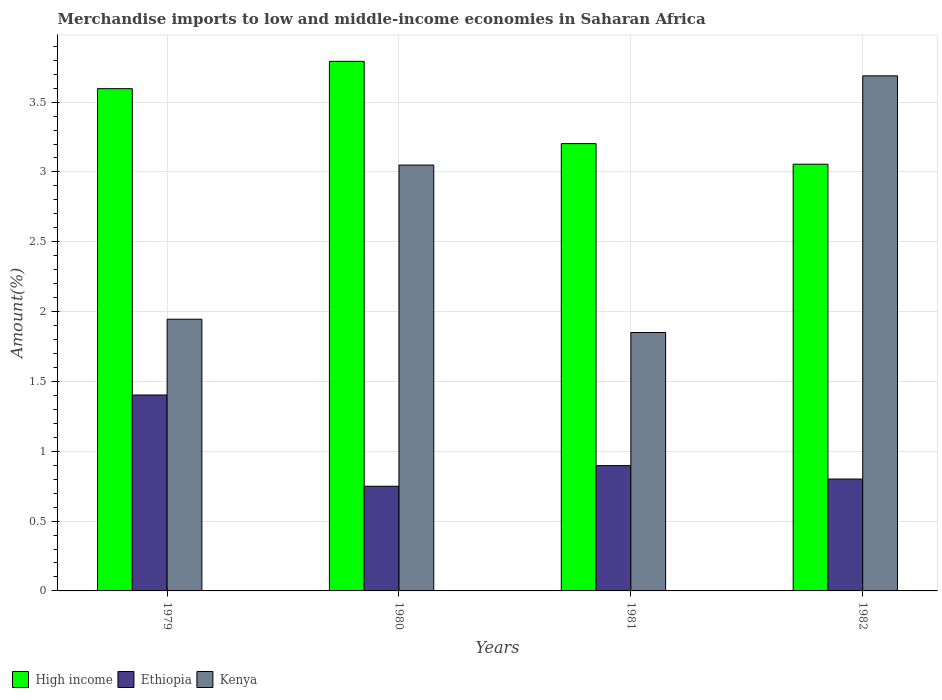How many different coloured bars are there?
Offer a very short reply. 3. How many groups of bars are there?
Ensure brevity in your answer.  4. How many bars are there on the 4th tick from the right?
Your answer should be compact. 3. What is the label of the 2nd group of bars from the left?
Make the answer very short. 1980. What is the percentage of amount earned from merchandise imports in Ethiopia in 1980?
Offer a terse response. 0.75. Across all years, what is the maximum percentage of amount earned from merchandise imports in Ethiopia?
Keep it short and to the point. 1.4. Across all years, what is the minimum percentage of amount earned from merchandise imports in Ethiopia?
Your answer should be very brief. 0.75. In which year was the percentage of amount earned from merchandise imports in Ethiopia maximum?
Provide a succinct answer. 1979. What is the total percentage of amount earned from merchandise imports in Kenya in the graph?
Your answer should be very brief. 10.53. What is the difference between the percentage of amount earned from merchandise imports in Kenya in 1979 and that in 1982?
Make the answer very short. -1.74. What is the difference between the percentage of amount earned from merchandise imports in Ethiopia in 1981 and the percentage of amount earned from merchandise imports in Kenya in 1979?
Your answer should be compact. -1.05. What is the average percentage of amount earned from merchandise imports in High income per year?
Make the answer very short. 3.41. In the year 1982, what is the difference between the percentage of amount earned from merchandise imports in Ethiopia and percentage of amount earned from merchandise imports in High income?
Make the answer very short. -2.25. In how many years, is the percentage of amount earned from merchandise imports in Kenya greater than 0.1 %?
Offer a terse response. 4. What is the ratio of the percentage of amount earned from merchandise imports in Ethiopia in 1980 to that in 1981?
Give a very brief answer. 0.84. What is the difference between the highest and the second highest percentage of amount earned from merchandise imports in High income?
Offer a very short reply. 0.2. What is the difference between the highest and the lowest percentage of amount earned from merchandise imports in Ethiopia?
Provide a succinct answer. 0.65. In how many years, is the percentage of amount earned from merchandise imports in Kenya greater than the average percentage of amount earned from merchandise imports in Kenya taken over all years?
Provide a short and direct response. 2. What does the 3rd bar from the left in 1979 represents?
Keep it short and to the point. Kenya. What does the 1st bar from the right in 1979 represents?
Make the answer very short. Kenya. Is it the case that in every year, the sum of the percentage of amount earned from merchandise imports in High income and percentage of amount earned from merchandise imports in Ethiopia is greater than the percentage of amount earned from merchandise imports in Kenya?
Your answer should be compact. Yes. How many bars are there?
Provide a succinct answer. 12. What is the difference between two consecutive major ticks on the Y-axis?
Your answer should be compact. 0.5. Are the values on the major ticks of Y-axis written in scientific E-notation?
Your answer should be very brief. No. Does the graph contain any zero values?
Keep it short and to the point. No. Does the graph contain grids?
Make the answer very short. Yes. Where does the legend appear in the graph?
Offer a very short reply. Bottom left. How many legend labels are there?
Your answer should be very brief. 3. How are the legend labels stacked?
Ensure brevity in your answer.  Horizontal. What is the title of the graph?
Ensure brevity in your answer.  Merchandise imports to low and middle-income economies in Saharan Africa. Does "Panama" appear as one of the legend labels in the graph?
Give a very brief answer. No. What is the label or title of the Y-axis?
Keep it short and to the point. Amount(%). What is the Amount(%) in High income in 1979?
Your response must be concise. 3.6. What is the Amount(%) of Ethiopia in 1979?
Keep it short and to the point. 1.4. What is the Amount(%) in Kenya in 1979?
Ensure brevity in your answer.  1.95. What is the Amount(%) of High income in 1980?
Provide a short and direct response. 3.79. What is the Amount(%) of Ethiopia in 1980?
Keep it short and to the point. 0.75. What is the Amount(%) of Kenya in 1980?
Keep it short and to the point. 3.05. What is the Amount(%) of High income in 1981?
Offer a very short reply. 3.2. What is the Amount(%) in Ethiopia in 1981?
Ensure brevity in your answer.  0.9. What is the Amount(%) in Kenya in 1981?
Your answer should be very brief. 1.85. What is the Amount(%) of High income in 1982?
Your answer should be very brief. 3.06. What is the Amount(%) in Ethiopia in 1982?
Provide a short and direct response. 0.8. What is the Amount(%) of Kenya in 1982?
Make the answer very short. 3.69. Across all years, what is the maximum Amount(%) in High income?
Offer a terse response. 3.79. Across all years, what is the maximum Amount(%) of Ethiopia?
Ensure brevity in your answer.  1.4. Across all years, what is the maximum Amount(%) in Kenya?
Make the answer very short. 3.69. Across all years, what is the minimum Amount(%) in High income?
Give a very brief answer. 3.06. Across all years, what is the minimum Amount(%) in Ethiopia?
Ensure brevity in your answer.  0.75. Across all years, what is the minimum Amount(%) of Kenya?
Your answer should be compact. 1.85. What is the total Amount(%) of High income in the graph?
Your answer should be compact. 13.65. What is the total Amount(%) in Ethiopia in the graph?
Provide a succinct answer. 3.85. What is the total Amount(%) of Kenya in the graph?
Offer a very short reply. 10.53. What is the difference between the Amount(%) of High income in 1979 and that in 1980?
Provide a short and direct response. -0.2. What is the difference between the Amount(%) in Ethiopia in 1979 and that in 1980?
Offer a very short reply. 0.65. What is the difference between the Amount(%) in Kenya in 1979 and that in 1980?
Offer a very short reply. -1.1. What is the difference between the Amount(%) of High income in 1979 and that in 1981?
Your answer should be compact. 0.39. What is the difference between the Amount(%) of Ethiopia in 1979 and that in 1981?
Keep it short and to the point. 0.51. What is the difference between the Amount(%) of Kenya in 1979 and that in 1981?
Make the answer very short. 0.09. What is the difference between the Amount(%) in High income in 1979 and that in 1982?
Your response must be concise. 0.54. What is the difference between the Amount(%) in Ethiopia in 1979 and that in 1982?
Your response must be concise. 0.6. What is the difference between the Amount(%) of Kenya in 1979 and that in 1982?
Give a very brief answer. -1.74. What is the difference between the Amount(%) in High income in 1980 and that in 1981?
Your answer should be compact. 0.59. What is the difference between the Amount(%) in Ethiopia in 1980 and that in 1981?
Your response must be concise. -0.15. What is the difference between the Amount(%) in Kenya in 1980 and that in 1981?
Offer a very short reply. 1.2. What is the difference between the Amount(%) of High income in 1980 and that in 1982?
Provide a succinct answer. 0.74. What is the difference between the Amount(%) in Ethiopia in 1980 and that in 1982?
Your response must be concise. -0.05. What is the difference between the Amount(%) of Kenya in 1980 and that in 1982?
Your answer should be compact. -0.64. What is the difference between the Amount(%) in High income in 1981 and that in 1982?
Your response must be concise. 0.15. What is the difference between the Amount(%) in Ethiopia in 1981 and that in 1982?
Provide a succinct answer. 0.1. What is the difference between the Amount(%) in Kenya in 1981 and that in 1982?
Make the answer very short. -1.84. What is the difference between the Amount(%) of High income in 1979 and the Amount(%) of Ethiopia in 1980?
Provide a short and direct response. 2.85. What is the difference between the Amount(%) in High income in 1979 and the Amount(%) in Kenya in 1980?
Your response must be concise. 0.55. What is the difference between the Amount(%) of Ethiopia in 1979 and the Amount(%) of Kenya in 1980?
Keep it short and to the point. -1.65. What is the difference between the Amount(%) in High income in 1979 and the Amount(%) in Ethiopia in 1981?
Your answer should be very brief. 2.7. What is the difference between the Amount(%) of High income in 1979 and the Amount(%) of Kenya in 1981?
Ensure brevity in your answer.  1.75. What is the difference between the Amount(%) in Ethiopia in 1979 and the Amount(%) in Kenya in 1981?
Offer a very short reply. -0.45. What is the difference between the Amount(%) in High income in 1979 and the Amount(%) in Ethiopia in 1982?
Offer a very short reply. 2.8. What is the difference between the Amount(%) in High income in 1979 and the Amount(%) in Kenya in 1982?
Provide a short and direct response. -0.09. What is the difference between the Amount(%) in Ethiopia in 1979 and the Amount(%) in Kenya in 1982?
Keep it short and to the point. -2.29. What is the difference between the Amount(%) in High income in 1980 and the Amount(%) in Ethiopia in 1981?
Offer a terse response. 2.89. What is the difference between the Amount(%) in High income in 1980 and the Amount(%) in Kenya in 1981?
Provide a succinct answer. 1.94. What is the difference between the Amount(%) of Ethiopia in 1980 and the Amount(%) of Kenya in 1981?
Offer a terse response. -1.1. What is the difference between the Amount(%) of High income in 1980 and the Amount(%) of Ethiopia in 1982?
Give a very brief answer. 2.99. What is the difference between the Amount(%) of High income in 1980 and the Amount(%) of Kenya in 1982?
Your answer should be very brief. 0.1. What is the difference between the Amount(%) in Ethiopia in 1980 and the Amount(%) in Kenya in 1982?
Provide a succinct answer. -2.94. What is the difference between the Amount(%) in High income in 1981 and the Amount(%) in Ethiopia in 1982?
Provide a succinct answer. 2.4. What is the difference between the Amount(%) of High income in 1981 and the Amount(%) of Kenya in 1982?
Keep it short and to the point. -0.49. What is the difference between the Amount(%) of Ethiopia in 1981 and the Amount(%) of Kenya in 1982?
Offer a very short reply. -2.79. What is the average Amount(%) in High income per year?
Offer a terse response. 3.41. What is the average Amount(%) of Ethiopia per year?
Offer a very short reply. 0.96. What is the average Amount(%) in Kenya per year?
Your response must be concise. 2.63. In the year 1979, what is the difference between the Amount(%) of High income and Amount(%) of Ethiopia?
Provide a short and direct response. 2.19. In the year 1979, what is the difference between the Amount(%) of High income and Amount(%) of Kenya?
Provide a succinct answer. 1.65. In the year 1979, what is the difference between the Amount(%) of Ethiopia and Amount(%) of Kenya?
Your answer should be compact. -0.54. In the year 1980, what is the difference between the Amount(%) in High income and Amount(%) in Ethiopia?
Give a very brief answer. 3.04. In the year 1980, what is the difference between the Amount(%) in High income and Amount(%) in Kenya?
Your answer should be very brief. 0.74. In the year 1980, what is the difference between the Amount(%) of Ethiopia and Amount(%) of Kenya?
Your answer should be compact. -2.3. In the year 1981, what is the difference between the Amount(%) of High income and Amount(%) of Ethiopia?
Your answer should be compact. 2.31. In the year 1981, what is the difference between the Amount(%) in High income and Amount(%) in Kenya?
Your response must be concise. 1.35. In the year 1981, what is the difference between the Amount(%) in Ethiopia and Amount(%) in Kenya?
Provide a short and direct response. -0.95. In the year 1982, what is the difference between the Amount(%) in High income and Amount(%) in Ethiopia?
Provide a succinct answer. 2.25. In the year 1982, what is the difference between the Amount(%) in High income and Amount(%) in Kenya?
Ensure brevity in your answer.  -0.63. In the year 1982, what is the difference between the Amount(%) of Ethiopia and Amount(%) of Kenya?
Offer a terse response. -2.89. What is the ratio of the Amount(%) in High income in 1979 to that in 1980?
Give a very brief answer. 0.95. What is the ratio of the Amount(%) of Ethiopia in 1979 to that in 1980?
Your response must be concise. 1.87. What is the ratio of the Amount(%) in Kenya in 1979 to that in 1980?
Offer a very short reply. 0.64. What is the ratio of the Amount(%) in High income in 1979 to that in 1981?
Your answer should be very brief. 1.12. What is the ratio of the Amount(%) in Ethiopia in 1979 to that in 1981?
Provide a succinct answer. 1.56. What is the ratio of the Amount(%) of Kenya in 1979 to that in 1981?
Provide a short and direct response. 1.05. What is the ratio of the Amount(%) in High income in 1979 to that in 1982?
Provide a short and direct response. 1.18. What is the ratio of the Amount(%) of Ethiopia in 1979 to that in 1982?
Give a very brief answer. 1.75. What is the ratio of the Amount(%) of Kenya in 1979 to that in 1982?
Your answer should be very brief. 0.53. What is the ratio of the Amount(%) in High income in 1980 to that in 1981?
Your answer should be very brief. 1.18. What is the ratio of the Amount(%) in Ethiopia in 1980 to that in 1981?
Your response must be concise. 0.84. What is the ratio of the Amount(%) in Kenya in 1980 to that in 1981?
Ensure brevity in your answer.  1.65. What is the ratio of the Amount(%) of High income in 1980 to that in 1982?
Your answer should be very brief. 1.24. What is the ratio of the Amount(%) in Ethiopia in 1980 to that in 1982?
Your response must be concise. 0.94. What is the ratio of the Amount(%) of Kenya in 1980 to that in 1982?
Provide a short and direct response. 0.83. What is the ratio of the Amount(%) in High income in 1981 to that in 1982?
Your response must be concise. 1.05. What is the ratio of the Amount(%) in Ethiopia in 1981 to that in 1982?
Offer a terse response. 1.12. What is the ratio of the Amount(%) in Kenya in 1981 to that in 1982?
Provide a succinct answer. 0.5. What is the difference between the highest and the second highest Amount(%) in High income?
Keep it short and to the point. 0.2. What is the difference between the highest and the second highest Amount(%) of Ethiopia?
Offer a very short reply. 0.51. What is the difference between the highest and the second highest Amount(%) in Kenya?
Your answer should be compact. 0.64. What is the difference between the highest and the lowest Amount(%) of High income?
Your response must be concise. 0.74. What is the difference between the highest and the lowest Amount(%) of Ethiopia?
Your response must be concise. 0.65. What is the difference between the highest and the lowest Amount(%) of Kenya?
Offer a terse response. 1.84. 